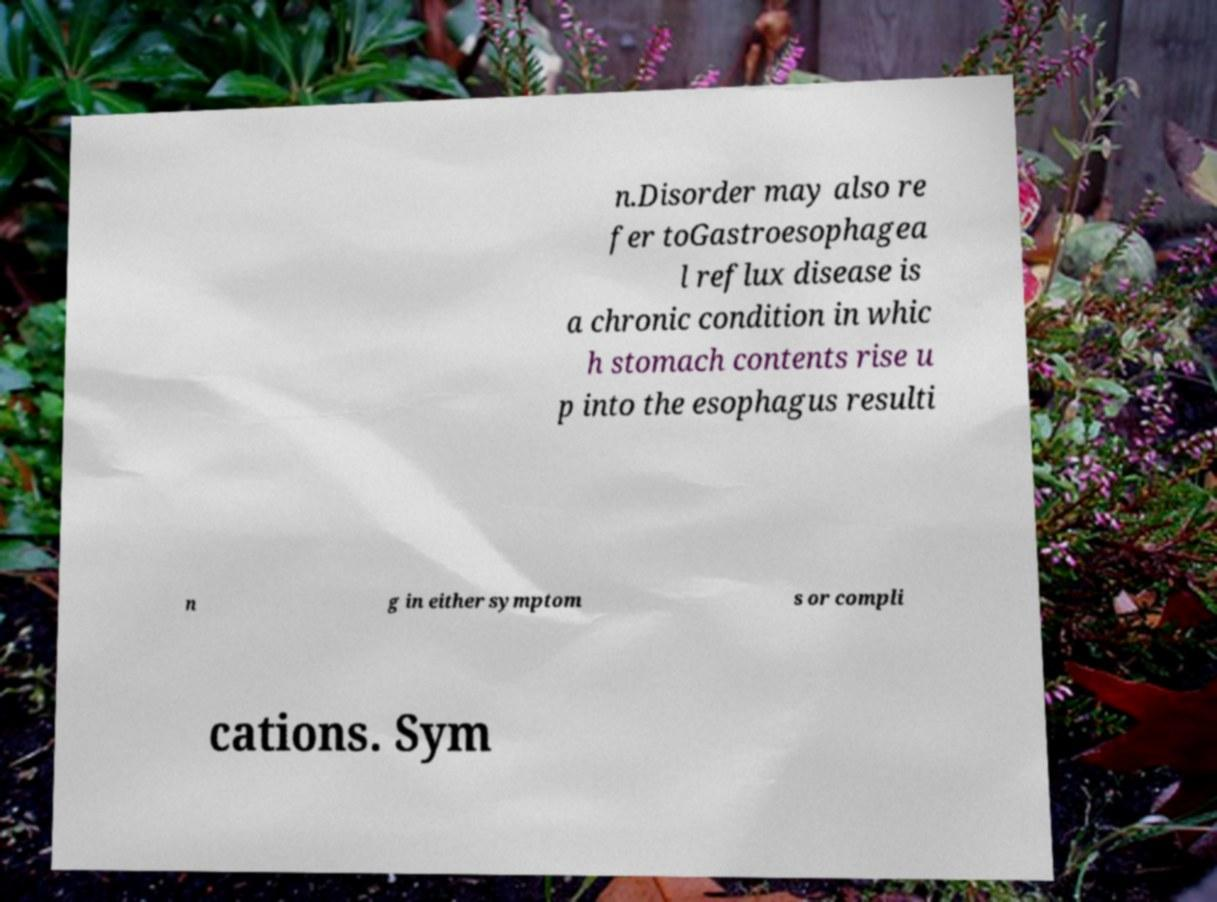I need the written content from this picture converted into text. Can you do that? n.Disorder may also re fer toGastroesophagea l reflux disease is a chronic condition in whic h stomach contents rise u p into the esophagus resulti n g in either symptom s or compli cations. Sym 